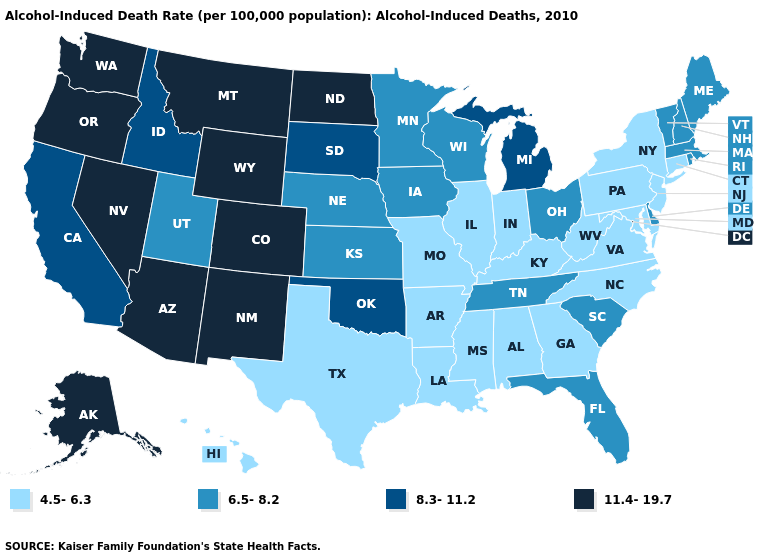Does North Dakota have the highest value in the USA?
Concise answer only. Yes. What is the lowest value in the USA?
Write a very short answer. 4.5-6.3. What is the lowest value in the South?
Concise answer only. 4.5-6.3. Which states have the highest value in the USA?
Write a very short answer. Alaska, Arizona, Colorado, Montana, Nevada, New Mexico, North Dakota, Oregon, Washington, Wyoming. Name the states that have a value in the range 11.4-19.7?
Write a very short answer. Alaska, Arizona, Colorado, Montana, Nevada, New Mexico, North Dakota, Oregon, Washington, Wyoming. Name the states that have a value in the range 4.5-6.3?
Give a very brief answer. Alabama, Arkansas, Connecticut, Georgia, Hawaii, Illinois, Indiana, Kentucky, Louisiana, Maryland, Mississippi, Missouri, New Jersey, New York, North Carolina, Pennsylvania, Texas, Virginia, West Virginia. What is the highest value in states that border West Virginia?
Concise answer only. 6.5-8.2. Does the first symbol in the legend represent the smallest category?
Keep it brief. Yes. Which states have the lowest value in the South?
Be succinct. Alabama, Arkansas, Georgia, Kentucky, Louisiana, Maryland, Mississippi, North Carolina, Texas, Virginia, West Virginia. Name the states that have a value in the range 11.4-19.7?
Write a very short answer. Alaska, Arizona, Colorado, Montana, Nevada, New Mexico, North Dakota, Oregon, Washington, Wyoming. Is the legend a continuous bar?
Answer briefly. No. Name the states that have a value in the range 4.5-6.3?
Be succinct. Alabama, Arkansas, Connecticut, Georgia, Hawaii, Illinois, Indiana, Kentucky, Louisiana, Maryland, Mississippi, Missouri, New Jersey, New York, North Carolina, Pennsylvania, Texas, Virginia, West Virginia. Does Maine have the lowest value in the Northeast?
Write a very short answer. No. Name the states that have a value in the range 8.3-11.2?
Be succinct. California, Idaho, Michigan, Oklahoma, South Dakota. 